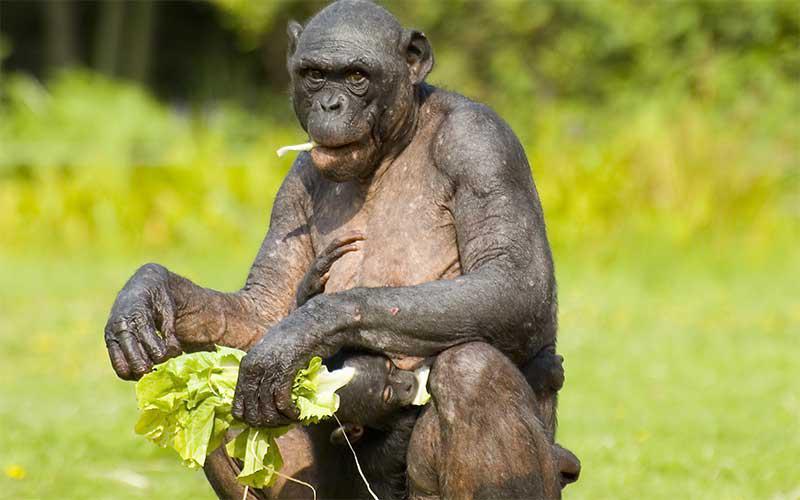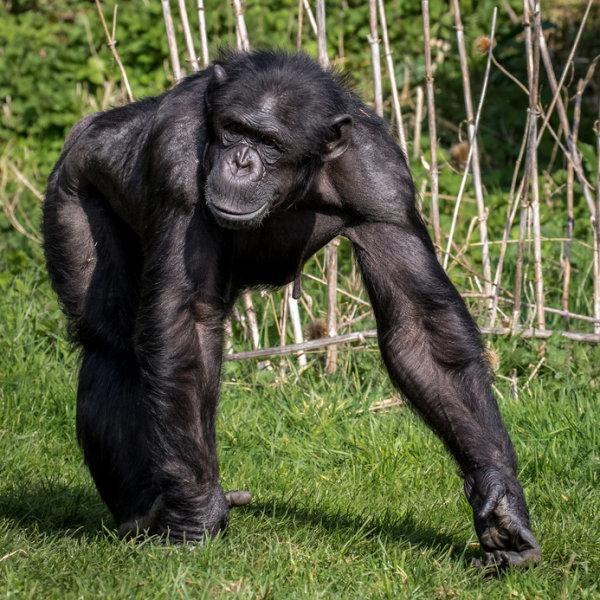The first image is the image on the left, the second image is the image on the right. Considering the images on both sides, is "There are four monkey-type animals including very young ones." valid? Answer yes or no. No. 